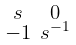<formula> <loc_0><loc_0><loc_500><loc_500>\begin{smallmatrix} s & 0 \\ - 1 & s ^ { - 1 } \end{smallmatrix}</formula> 